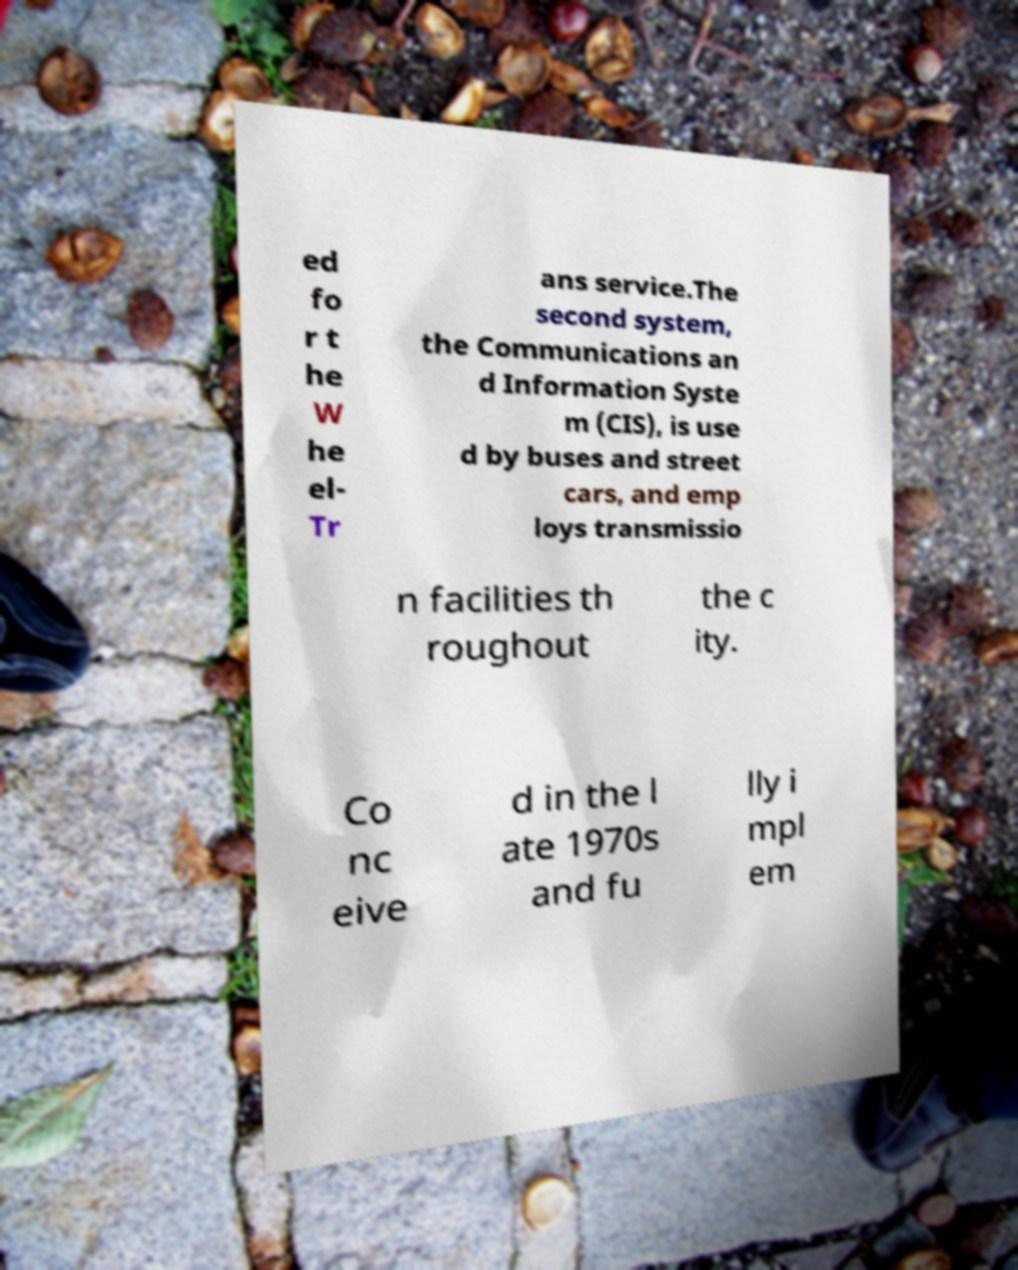Can you read and provide the text displayed in the image?This photo seems to have some interesting text. Can you extract and type it out for me? ed fo r t he W he el- Tr ans service.The second system, the Communications an d Information Syste m (CIS), is use d by buses and street cars, and emp loys transmissio n facilities th roughout the c ity. Co nc eive d in the l ate 1970s and fu lly i mpl em 